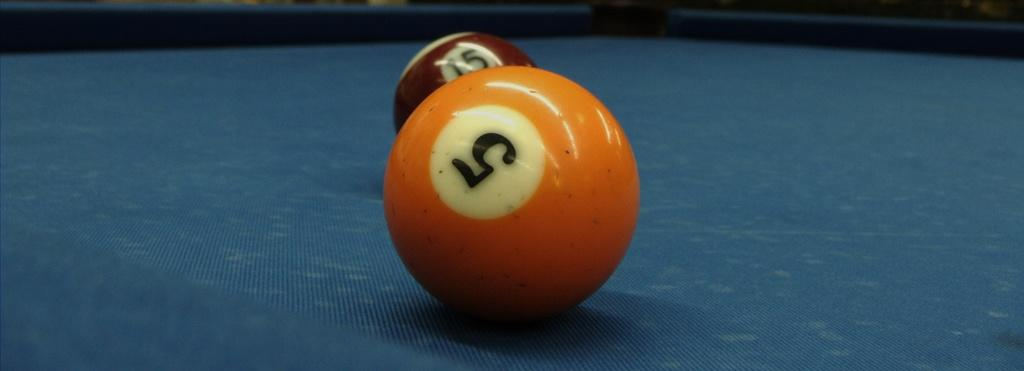What objects are present in the image? There are two balls in the image. Where are the balls located? The balls are on a pool table. Can you see a squirrel building a nest in the image? There is no squirrel or nest present in the image; it features two balls on a pool table. Is there a hole in the image? There is no hole mentioned or visible in the image. 